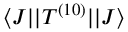<formula> <loc_0><loc_0><loc_500><loc_500>\langle J | | T ^ { ( 1 0 ) } | | J \rangle</formula> 